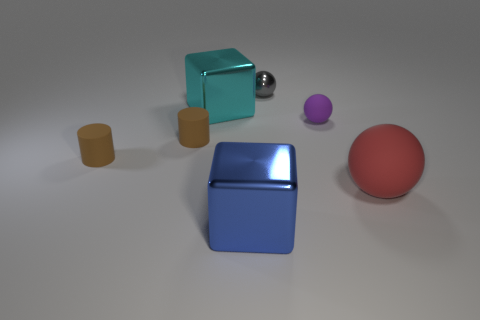How many brown cylinders must be subtracted to get 1 brown cylinders? 1 Subtract all gray spheres. How many spheres are left? 2 Subtract all cyan cubes. How many cubes are left? 1 Subtract all cubes. How many objects are left? 5 Add 1 tiny gray shiny balls. How many tiny gray shiny balls are left? 2 Add 7 tiny red blocks. How many tiny red blocks exist? 7 Add 3 brown cylinders. How many objects exist? 10 Subtract 0 yellow cubes. How many objects are left? 7 Subtract 1 cubes. How many cubes are left? 1 Subtract all purple cylinders. Subtract all brown spheres. How many cylinders are left? 2 